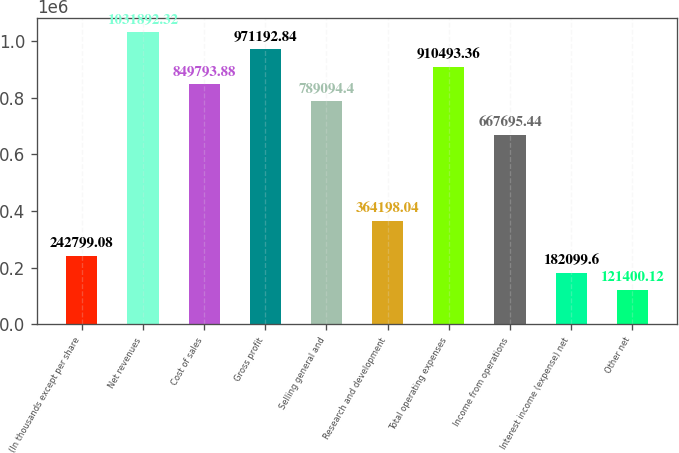<chart> <loc_0><loc_0><loc_500><loc_500><bar_chart><fcel>(In thousands except per share<fcel>Net revenues<fcel>Cost of sales<fcel>Gross profit<fcel>Selling general and<fcel>Research and development<fcel>Total operating expenses<fcel>Income from operations<fcel>Interest income (expense) net<fcel>Other net<nl><fcel>242799<fcel>1.03189e+06<fcel>849794<fcel>971193<fcel>789094<fcel>364198<fcel>910493<fcel>667695<fcel>182100<fcel>121400<nl></chart> 